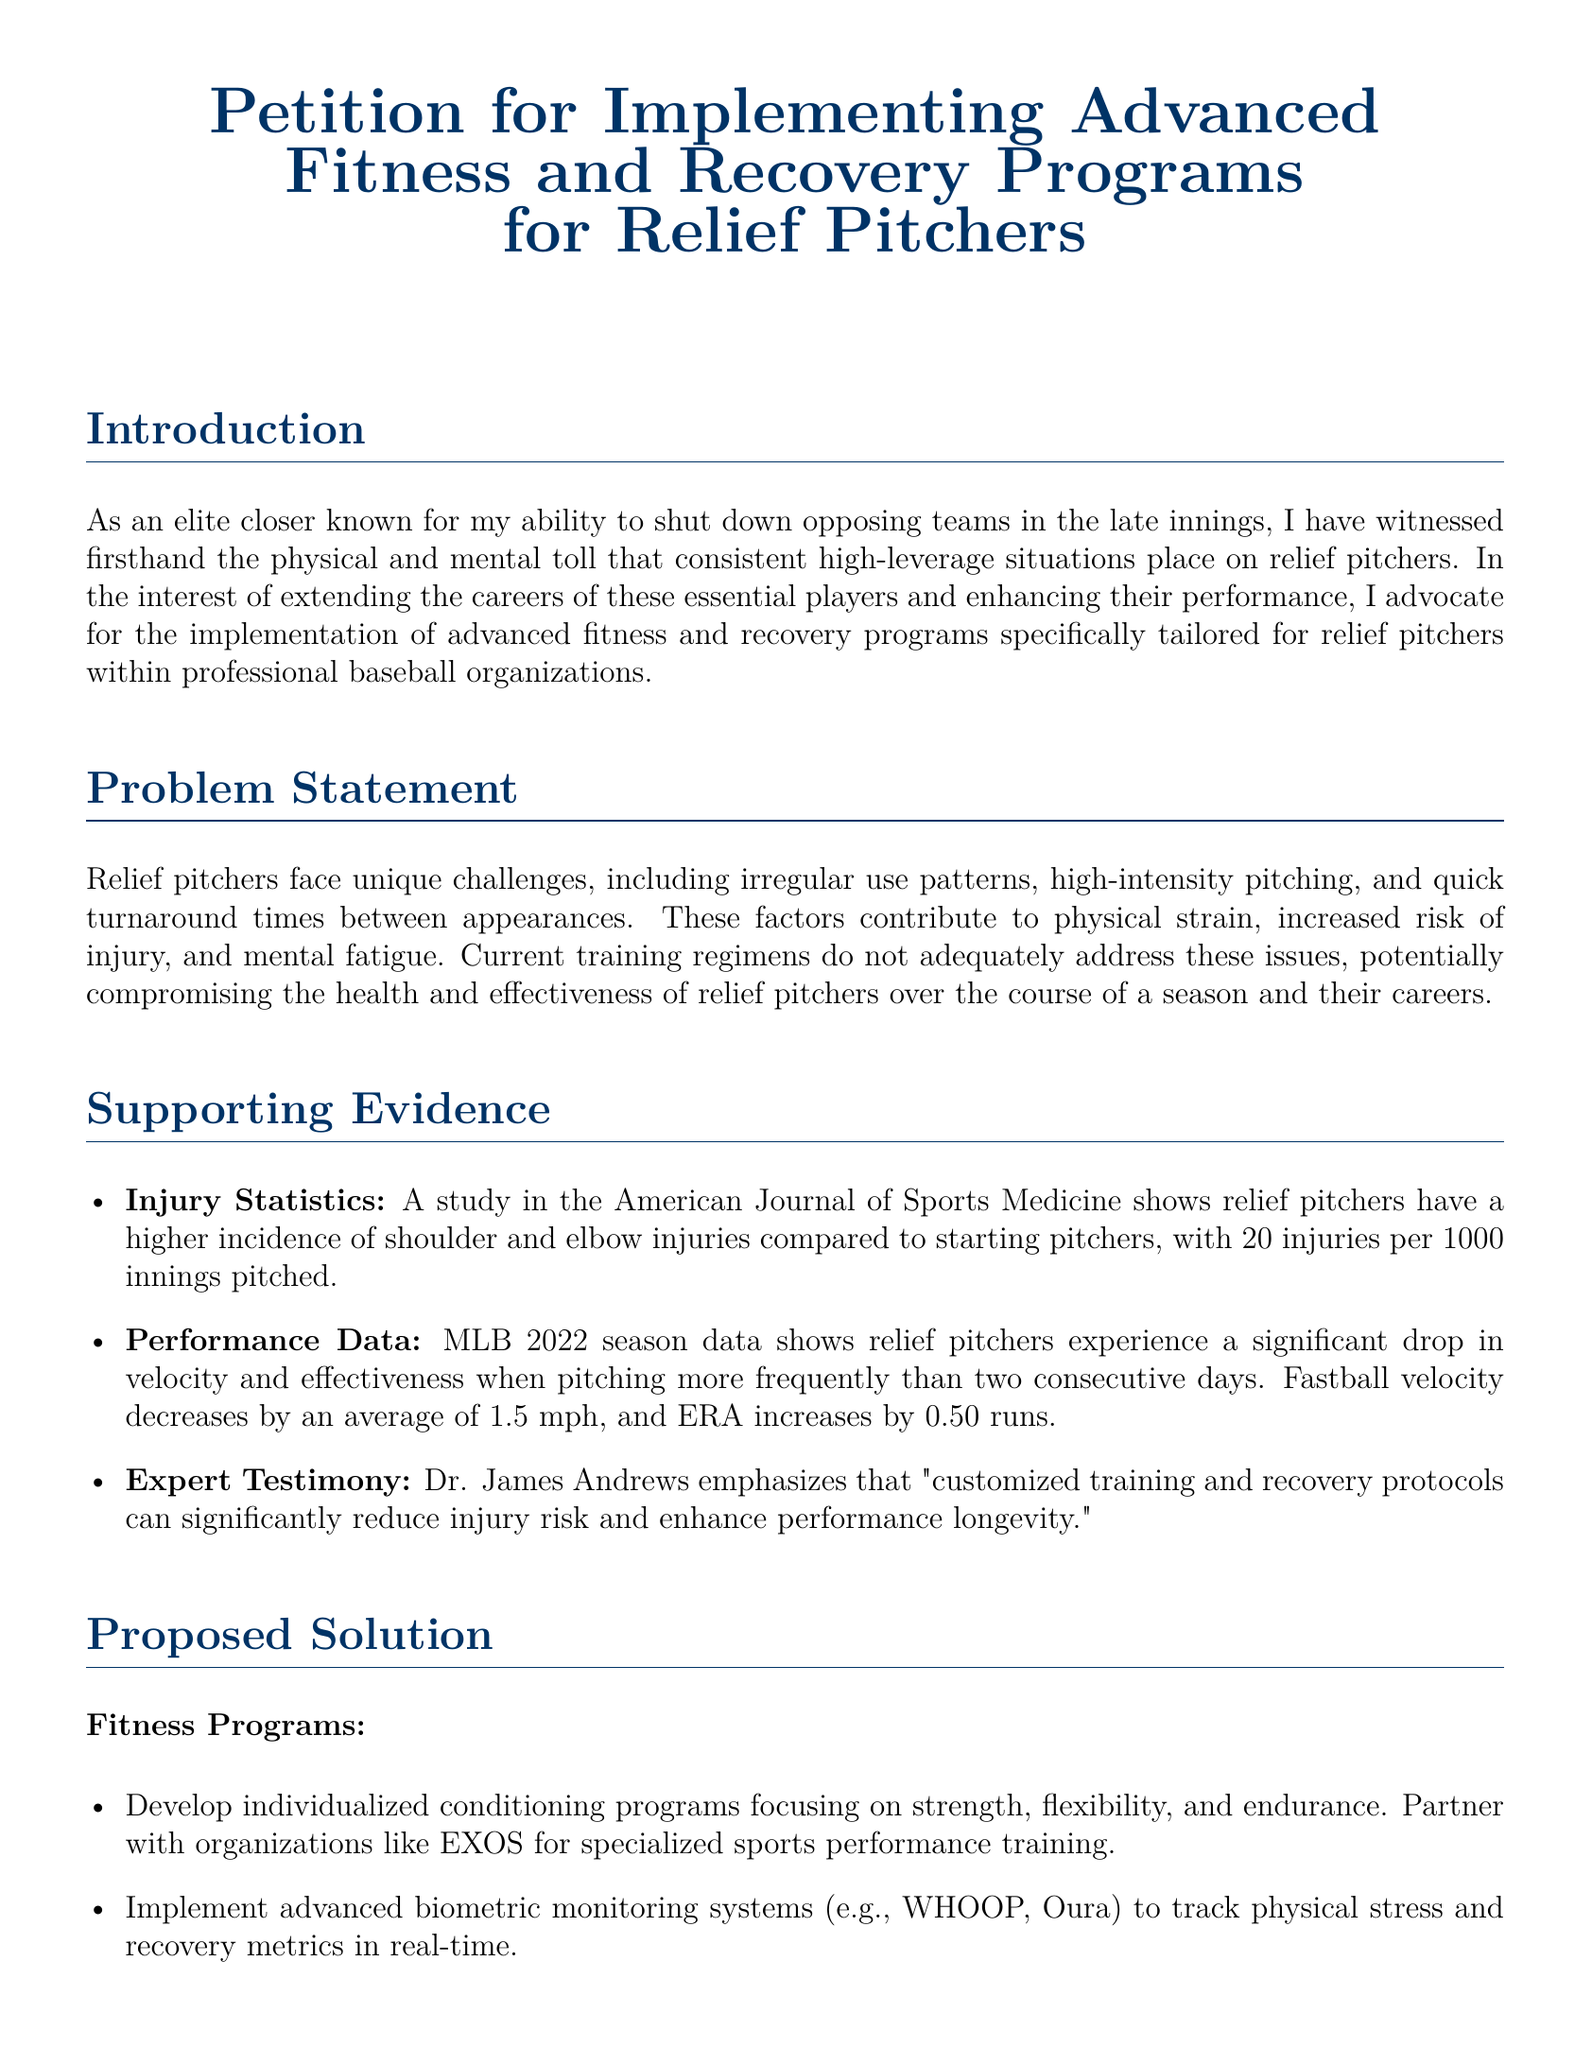What is the main subject of the petition? The petition focuses on the implementation of fitness and recovery programs specifically for relief pitchers in professional baseball organizations.
Answer: Advanced Fitness and Recovery Programs for Relief Pitchers How many injuries do relief pitchers experience per 1000 innings pitched? The document states that relief pitchers have 20 injuries per 1000 innings pitched.
Answer: 20 What is one advanced recovery technique mentioned in the petition? The petition lists cryotherapy, hydrotherapy, and NormaTec compression therapy as advanced recovery techniques.
Answer: Cryotherapy Who is referenced as an expert in the petition? The document cites Dr. James Andrews as a key expert providing testimony on training and recovery protocols.
Answer: Dr. James Andrews What is one proposed solution for fitness programs? The petition suggests developing individualized conditioning programs that focus on strength, flexibility, and endurance.
Answer: Individualized conditioning programs What decreases by an average of 1.5 mph when relief pitchers pitch frequently? According to the document, fastball velocity decreases by an average of 1.5 mph with frequent pitching.
Answer: Fastball velocity What does the petition urge from stakeholders in the baseball community? The petition calls for stakeholders to support implementing specialized fitness and recovery programs for relief pitchers.
Answer: Support this petition Which organization is mentioned for partnership in developing fitness programs? The petition suggests partnering with EXOS for specialized sports performance training.
Answer: EXOS 